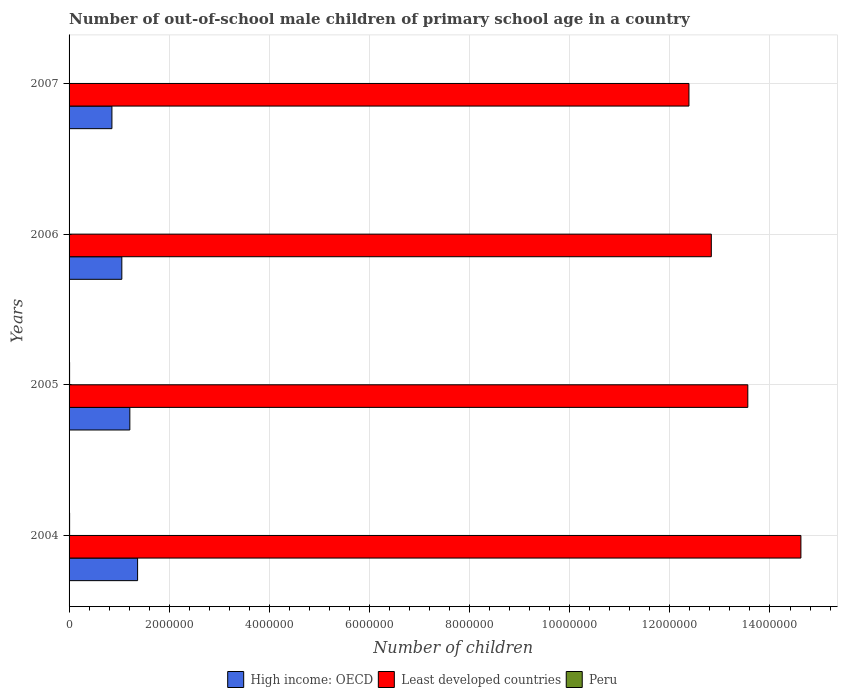Are the number of bars per tick equal to the number of legend labels?
Ensure brevity in your answer.  Yes. Are the number of bars on each tick of the Y-axis equal?
Provide a short and direct response. Yes. How many bars are there on the 3rd tick from the top?
Make the answer very short. 3. How many bars are there on the 4th tick from the bottom?
Your answer should be very brief. 3. What is the label of the 4th group of bars from the top?
Ensure brevity in your answer.  2004. What is the number of out-of-school male children in Peru in 2004?
Make the answer very short. 1.08e+04. Across all years, what is the maximum number of out-of-school male children in High income: OECD?
Keep it short and to the point. 1.37e+06. Across all years, what is the minimum number of out-of-school male children in High income: OECD?
Your answer should be compact. 8.56e+05. In which year was the number of out-of-school male children in Peru maximum?
Your response must be concise. 2004. What is the total number of out-of-school male children in Peru in the graph?
Ensure brevity in your answer.  3.63e+04. What is the difference between the number of out-of-school male children in High income: OECD in 2004 and that in 2007?
Offer a very short reply. 5.13e+05. What is the difference between the number of out-of-school male children in Least developed countries in 2006 and the number of out-of-school male children in High income: OECD in 2007?
Make the answer very short. 1.20e+07. What is the average number of out-of-school male children in High income: OECD per year?
Your answer should be compact. 1.12e+06. In the year 2005, what is the difference between the number of out-of-school male children in Least developed countries and number of out-of-school male children in Peru?
Ensure brevity in your answer.  1.35e+07. What is the ratio of the number of out-of-school male children in Least developed countries in 2004 to that in 2005?
Offer a terse response. 1.08. What is the difference between the highest and the second highest number of out-of-school male children in High income: OECD?
Provide a succinct answer. 1.55e+05. What is the difference between the highest and the lowest number of out-of-school male children in Least developed countries?
Ensure brevity in your answer.  2.24e+06. In how many years, is the number of out-of-school male children in Least developed countries greater than the average number of out-of-school male children in Least developed countries taken over all years?
Offer a very short reply. 2. How many bars are there?
Make the answer very short. 12. Does the graph contain grids?
Your answer should be very brief. Yes. How many legend labels are there?
Offer a terse response. 3. What is the title of the graph?
Your answer should be compact. Number of out-of-school male children of primary school age in a country. Does "Malaysia" appear as one of the legend labels in the graph?
Make the answer very short. No. What is the label or title of the X-axis?
Offer a terse response. Number of children. What is the label or title of the Y-axis?
Offer a very short reply. Years. What is the Number of children of High income: OECD in 2004?
Offer a very short reply. 1.37e+06. What is the Number of children of Least developed countries in 2004?
Offer a terse response. 1.46e+07. What is the Number of children of Peru in 2004?
Give a very brief answer. 1.08e+04. What is the Number of children of High income: OECD in 2005?
Give a very brief answer. 1.21e+06. What is the Number of children in Least developed countries in 2005?
Provide a short and direct response. 1.36e+07. What is the Number of children of Peru in 2005?
Your response must be concise. 1.06e+04. What is the Number of children in High income: OECD in 2006?
Offer a very short reply. 1.05e+06. What is the Number of children of Least developed countries in 2006?
Your answer should be very brief. 1.28e+07. What is the Number of children of Peru in 2006?
Make the answer very short. 7293. What is the Number of children of High income: OECD in 2007?
Offer a very short reply. 8.56e+05. What is the Number of children in Least developed countries in 2007?
Provide a succinct answer. 1.24e+07. What is the Number of children of Peru in 2007?
Give a very brief answer. 7691. Across all years, what is the maximum Number of children in High income: OECD?
Keep it short and to the point. 1.37e+06. Across all years, what is the maximum Number of children in Least developed countries?
Give a very brief answer. 1.46e+07. Across all years, what is the maximum Number of children of Peru?
Offer a terse response. 1.08e+04. Across all years, what is the minimum Number of children in High income: OECD?
Give a very brief answer. 8.56e+05. Across all years, what is the minimum Number of children in Least developed countries?
Your answer should be very brief. 1.24e+07. Across all years, what is the minimum Number of children of Peru?
Your response must be concise. 7293. What is the total Number of children in High income: OECD in the graph?
Your answer should be compact. 4.49e+06. What is the total Number of children of Least developed countries in the graph?
Ensure brevity in your answer.  5.34e+07. What is the total Number of children in Peru in the graph?
Provide a short and direct response. 3.63e+04. What is the difference between the Number of children in High income: OECD in 2004 and that in 2005?
Your answer should be compact. 1.55e+05. What is the difference between the Number of children of Least developed countries in 2004 and that in 2005?
Offer a very short reply. 1.06e+06. What is the difference between the Number of children of Peru in 2004 and that in 2005?
Provide a short and direct response. 203. What is the difference between the Number of children of High income: OECD in 2004 and that in 2006?
Give a very brief answer. 3.15e+05. What is the difference between the Number of children in Least developed countries in 2004 and that in 2006?
Give a very brief answer. 1.79e+06. What is the difference between the Number of children in Peru in 2004 and that in 2006?
Your answer should be compact. 3475. What is the difference between the Number of children in High income: OECD in 2004 and that in 2007?
Offer a very short reply. 5.13e+05. What is the difference between the Number of children of Least developed countries in 2004 and that in 2007?
Your answer should be compact. 2.24e+06. What is the difference between the Number of children in Peru in 2004 and that in 2007?
Ensure brevity in your answer.  3077. What is the difference between the Number of children in High income: OECD in 2005 and that in 2006?
Your response must be concise. 1.60e+05. What is the difference between the Number of children in Least developed countries in 2005 and that in 2006?
Your answer should be very brief. 7.29e+05. What is the difference between the Number of children of Peru in 2005 and that in 2006?
Offer a very short reply. 3272. What is the difference between the Number of children of High income: OECD in 2005 and that in 2007?
Your answer should be very brief. 3.58e+05. What is the difference between the Number of children in Least developed countries in 2005 and that in 2007?
Give a very brief answer. 1.18e+06. What is the difference between the Number of children of Peru in 2005 and that in 2007?
Offer a terse response. 2874. What is the difference between the Number of children of High income: OECD in 2006 and that in 2007?
Your answer should be very brief. 1.98e+05. What is the difference between the Number of children in Least developed countries in 2006 and that in 2007?
Your response must be concise. 4.47e+05. What is the difference between the Number of children of Peru in 2006 and that in 2007?
Provide a succinct answer. -398. What is the difference between the Number of children of High income: OECD in 2004 and the Number of children of Least developed countries in 2005?
Your response must be concise. -1.22e+07. What is the difference between the Number of children of High income: OECD in 2004 and the Number of children of Peru in 2005?
Your answer should be very brief. 1.36e+06. What is the difference between the Number of children in Least developed countries in 2004 and the Number of children in Peru in 2005?
Ensure brevity in your answer.  1.46e+07. What is the difference between the Number of children of High income: OECD in 2004 and the Number of children of Least developed countries in 2006?
Make the answer very short. -1.15e+07. What is the difference between the Number of children in High income: OECD in 2004 and the Number of children in Peru in 2006?
Provide a succinct answer. 1.36e+06. What is the difference between the Number of children of Least developed countries in 2004 and the Number of children of Peru in 2006?
Your response must be concise. 1.46e+07. What is the difference between the Number of children in High income: OECD in 2004 and the Number of children in Least developed countries in 2007?
Your answer should be compact. -1.10e+07. What is the difference between the Number of children in High income: OECD in 2004 and the Number of children in Peru in 2007?
Ensure brevity in your answer.  1.36e+06. What is the difference between the Number of children in Least developed countries in 2004 and the Number of children in Peru in 2007?
Offer a terse response. 1.46e+07. What is the difference between the Number of children in High income: OECD in 2005 and the Number of children in Least developed countries in 2006?
Offer a very short reply. -1.16e+07. What is the difference between the Number of children in High income: OECD in 2005 and the Number of children in Peru in 2006?
Make the answer very short. 1.21e+06. What is the difference between the Number of children of Least developed countries in 2005 and the Number of children of Peru in 2006?
Ensure brevity in your answer.  1.35e+07. What is the difference between the Number of children of High income: OECD in 2005 and the Number of children of Least developed countries in 2007?
Give a very brief answer. -1.12e+07. What is the difference between the Number of children in High income: OECD in 2005 and the Number of children in Peru in 2007?
Your answer should be compact. 1.21e+06. What is the difference between the Number of children of Least developed countries in 2005 and the Number of children of Peru in 2007?
Give a very brief answer. 1.35e+07. What is the difference between the Number of children in High income: OECD in 2006 and the Number of children in Least developed countries in 2007?
Ensure brevity in your answer.  -1.13e+07. What is the difference between the Number of children in High income: OECD in 2006 and the Number of children in Peru in 2007?
Your answer should be compact. 1.05e+06. What is the difference between the Number of children of Least developed countries in 2006 and the Number of children of Peru in 2007?
Keep it short and to the point. 1.28e+07. What is the average Number of children in High income: OECD per year?
Your answer should be very brief. 1.12e+06. What is the average Number of children of Least developed countries per year?
Ensure brevity in your answer.  1.33e+07. What is the average Number of children in Peru per year?
Provide a succinct answer. 9079.25. In the year 2004, what is the difference between the Number of children in High income: OECD and Number of children in Least developed countries?
Offer a very short reply. -1.32e+07. In the year 2004, what is the difference between the Number of children of High income: OECD and Number of children of Peru?
Your response must be concise. 1.36e+06. In the year 2004, what is the difference between the Number of children in Least developed countries and Number of children in Peru?
Ensure brevity in your answer.  1.46e+07. In the year 2005, what is the difference between the Number of children in High income: OECD and Number of children in Least developed countries?
Offer a terse response. -1.23e+07. In the year 2005, what is the difference between the Number of children of High income: OECD and Number of children of Peru?
Your response must be concise. 1.20e+06. In the year 2005, what is the difference between the Number of children of Least developed countries and Number of children of Peru?
Offer a very short reply. 1.35e+07. In the year 2006, what is the difference between the Number of children of High income: OECD and Number of children of Least developed countries?
Your answer should be very brief. -1.18e+07. In the year 2006, what is the difference between the Number of children in High income: OECD and Number of children in Peru?
Your answer should be compact. 1.05e+06. In the year 2006, what is the difference between the Number of children of Least developed countries and Number of children of Peru?
Ensure brevity in your answer.  1.28e+07. In the year 2007, what is the difference between the Number of children of High income: OECD and Number of children of Least developed countries?
Your answer should be very brief. -1.15e+07. In the year 2007, what is the difference between the Number of children of High income: OECD and Number of children of Peru?
Ensure brevity in your answer.  8.48e+05. In the year 2007, what is the difference between the Number of children in Least developed countries and Number of children in Peru?
Provide a short and direct response. 1.24e+07. What is the ratio of the Number of children in High income: OECD in 2004 to that in 2005?
Offer a very short reply. 1.13. What is the ratio of the Number of children in Least developed countries in 2004 to that in 2005?
Give a very brief answer. 1.08. What is the ratio of the Number of children in Peru in 2004 to that in 2005?
Your answer should be very brief. 1.02. What is the ratio of the Number of children in High income: OECD in 2004 to that in 2006?
Your answer should be very brief. 1.3. What is the ratio of the Number of children in Least developed countries in 2004 to that in 2006?
Provide a succinct answer. 1.14. What is the ratio of the Number of children of Peru in 2004 to that in 2006?
Your answer should be very brief. 1.48. What is the ratio of the Number of children of High income: OECD in 2004 to that in 2007?
Provide a succinct answer. 1.6. What is the ratio of the Number of children in Least developed countries in 2004 to that in 2007?
Provide a succinct answer. 1.18. What is the ratio of the Number of children of Peru in 2004 to that in 2007?
Provide a succinct answer. 1.4. What is the ratio of the Number of children in High income: OECD in 2005 to that in 2006?
Your response must be concise. 1.15. What is the ratio of the Number of children of Least developed countries in 2005 to that in 2006?
Offer a terse response. 1.06. What is the ratio of the Number of children in Peru in 2005 to that in 2006?
Offer a very short reply. 1.45. What is the ratio of the Number of children of High income: OECD in 2005 to that in 2007?
Ensure brevity in your answer.  1.42. What is the ratio of the Number of children in Least developed countries in 2005 to that in 2007?
Ensure brevity in your answer.  1.09. What is the ratio of the Number of children of Peru in 2005 to that in 2007?
Provide a succinct answer. 1.37. What is the ratio of the Number of children in High income: OECD in 2006 to that in 2007?
Your answer should be compact. 1.23. What is the ratio of the Number of children in Least developed countries in 2006 to that in 2007?
Give a very brief answer. 1.04. What is the ratio of the Number of children of Peru in 2006 to that in 2007?
Your answer should be very brief. 0.95. What is the difference between the highest and the second highest Number of children of High income: OECD?
Offer a terse response. 1.55e+05. What is the difference between the highest and the second highest Number of children of Least developed countries?
Ensure brevity in your answer.  1.06e+06. What is the difference between the highest and the second highest Number of children in Peru?
Your response must be concise. 203. What is the difference between the highest and the lowest Number of children of High income: OECD?
Provide a short and direct response. 5.13e+05. What is the difference between the highest and the lowest Number of children in Least developed countries?
Offer a very short reply. 2.24e+06. What is the difference between the highest and the lowest Number of children of Peru?
Provide a succinct answer. 3475. 